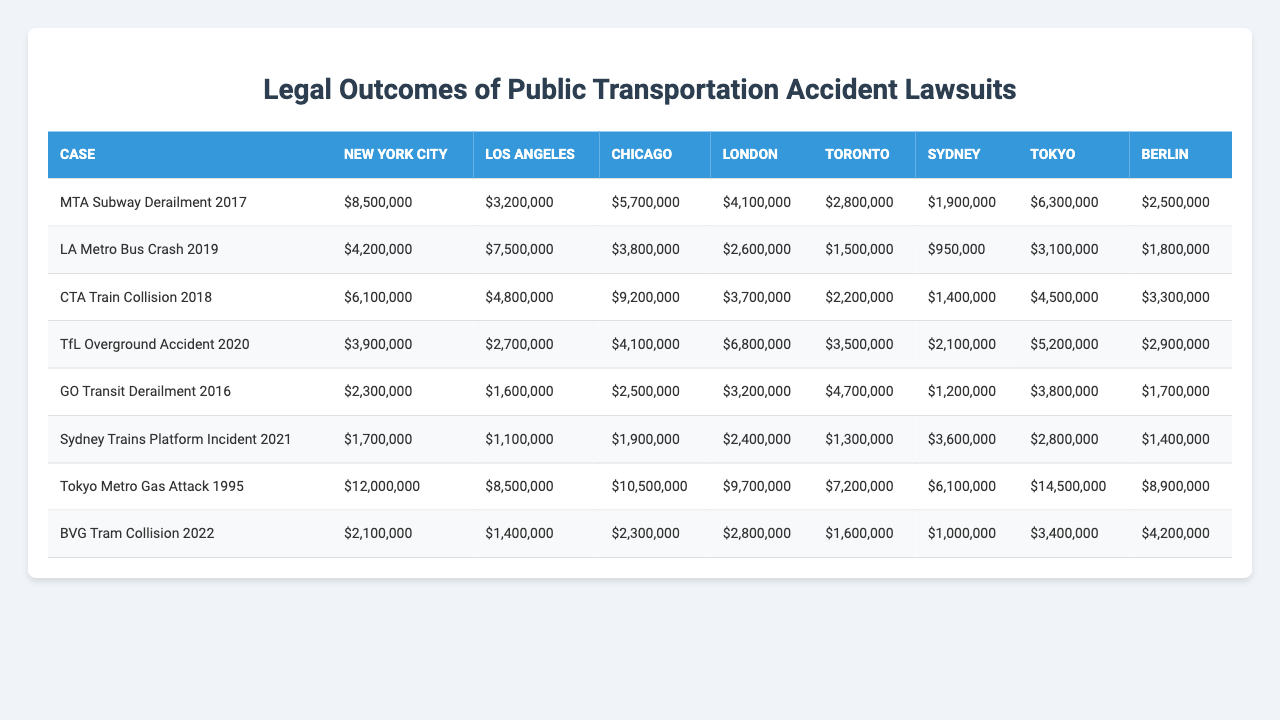What is the total amount awarded in New York City for the MTA Subway Derailment 2017? The amount awarded for the MTA Subway Derailment 2017 in New York City is $8,500,000, which is directly taken from the table for that specific case and jurisdiction.
Answer: $8,500,000 Which jurisdiction had the highest legal outcome for the Tokyo Metro Gas Attack 1995? The legal outcome for the Tokyo Metro Gas Attack 1995 in Tokyo jurisdiction is $12,000,000, which is the highest amount awarded for that case according to the table.
Answer: $12,000,000 What is the average legal outcome for the cases in Berlin? To find the average legal outcome for Berlin, we sum the amounts awarded in Berlin: $2,500,000 + $1,800,000 + $3,300,000 + $2,900,000 + $1,700,000 + $1,400,000 + $8,900,000 + $4,200,000 = $23,300,000, and then divide by the number of cases (8). The average is $23,300,000 / 8 = $2,912,500.
Answer: $2,912,500 Did Los Angeles have a higher sum of awards than Chicago for their respective cases? The total awards for Los Angeles are: $4,200,000 + $7,500,000 = $11,700,000, while for Chicago, it is: $6,100,000 + $4,800,000 = $10,900,000. Since $11,700,000 > $10,900,000, Los Angeles did have a higher total.
Answer: Yes Which case had the lowest award amount in Toronto, and what was it? In the Toronto column, the cases and respective award amounts are: $2,800,000 (MTA Subway Derailment), $2,600,000 (LA Metro Bus Crash), $3,700,000 (CTA Train Collision), $6,800,000 (TfL Overground Accident), $4,700,000 (GO Transit Derailment), $1,200,000 (Sydney Trains), $7,200,000 (Tokyo Metro), and $1,600,000 (BVG Tram). The lowest award amount is $1,200,000 for Sydney Trains.
Answer: $1,200,000 What is the difference between the highest and lowest legal award amounts in Sydney? The highest award in Sydney is $3,600,000 (Sydney Trains Platform Incident), and the lowest is $1,100,000 (BVG Tram Collision). The difference can be calculated as $3,600,000 - $1,100,000 = $2,500,000.
Answer: $2,500,000 How much total compensation was awarded for all cases in the jurisdictions combined? We compute the total compensation by adding all amounts from each case across all jurisdictions: ($8,500,000 + $4,200,000 + $6,100,000 + $3,900,000 + $2,300,000 + $1,700,000 + $12,000,000 + $2,100,000) = $40,100,000. This includes amounts from every jurisdiction and case listed in the table.
Answer: $40,100,000 Which jurisdiction awarded more than $8 million in multiple cases? Reviewing the table, it's evident that New York City awarded more than $8 million for the MTA Subway case and Tokyo also has an award greater than $8 million (Tokyo Metro Gas Attack). Thus, both New York City and Tokyo meet this condition of awarding over $8 million in multiple cases.
Answer: New York City and Tokyo 